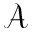Convert formula to latex. <formula><loc_0><loc_0><loc_500><loc_500>\mathcal { A }</formula> 